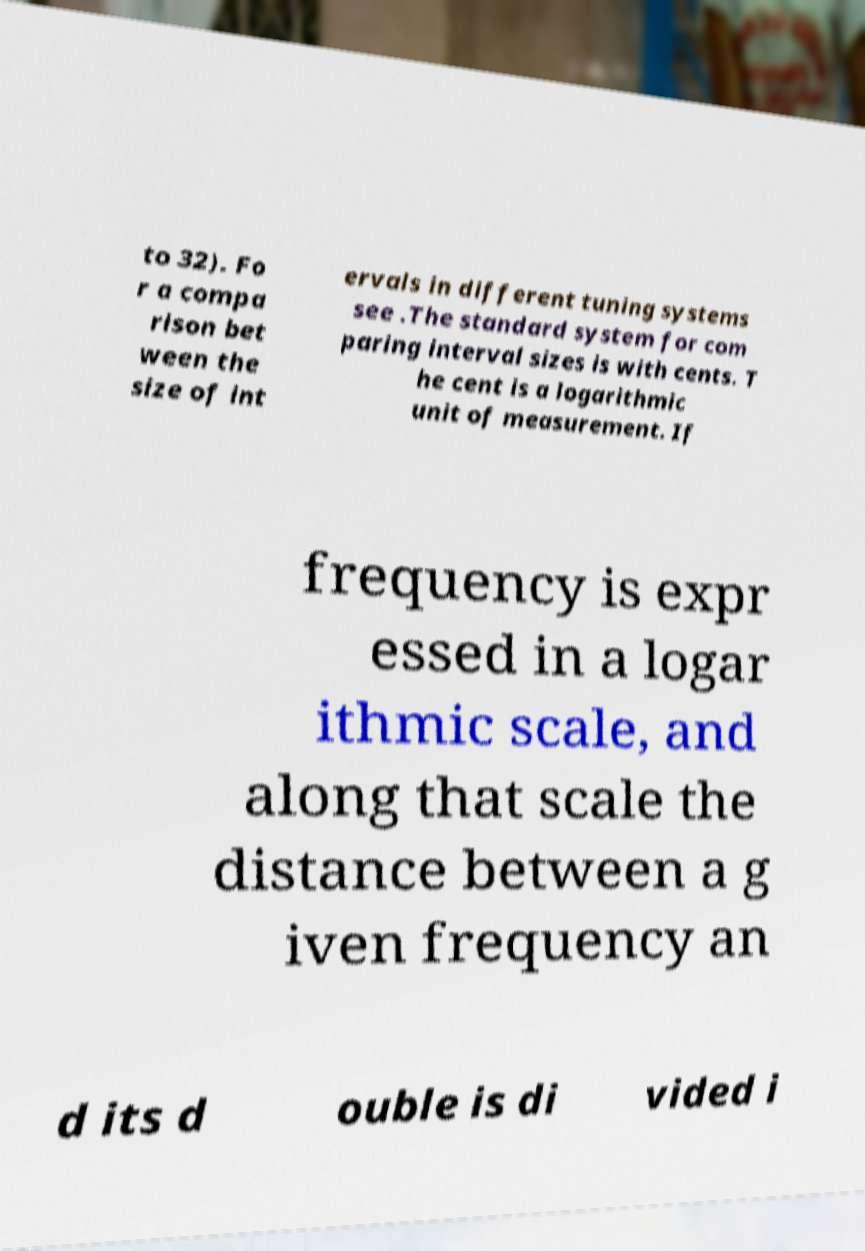Can you read and provide the text displayed in the image?This photo seems to have some interesting text. Can you extract and type it out for me? to 32). Fo r a compa rison bet ween the size of int ervals in different tuning systems see .The standard system for com paring interval sizes is with cents. T he cent is a logarithmic unit of measurement. If frequency is expr essed in a logar ithmic scale, and along that scale the distance between a g iven frequency an d its d ouble is di vided i 